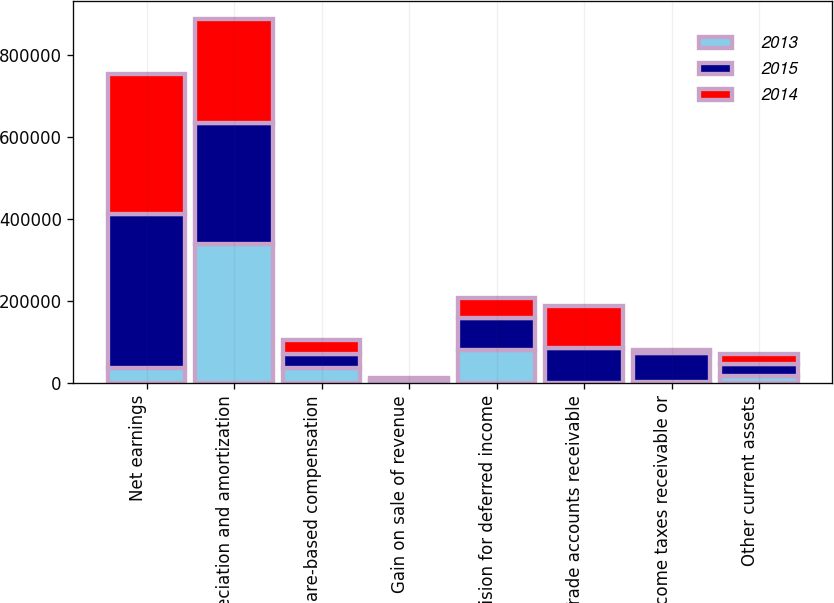Convert chart to OTSL. <chart><loc_0><loc_0><loc_500><loc_500><stacked_bar_chart><ecel><fcel>Net earnings<fcel>Depreciation and amortization<fcel>Share-based compensation<fcel>Gain on sale of revenue<fcel>Provision for deferred income<fcel>Trade accounts receivable<fcel>Income taxes receivable or<fcel>Other current assets<nl><fcel>2013<fcel>37228<fcel>339613<fcel>37228<fcel>1281<fcel>80427<fcel>747<fcel>3055<fcel>17735<nl><fcel>2015<fcel>374792<fcel>294496<fcel>35333<fcel>6342<fcel>79343<fcel>85276<fcel>72291<fcel>29793<nl><fcel>2014<fcel>342382<fcel>253380<fcel>32354<fcel>5334<fcel>48076<fcel>102508<fcel>5381<fcel>23254<nl></chart> 